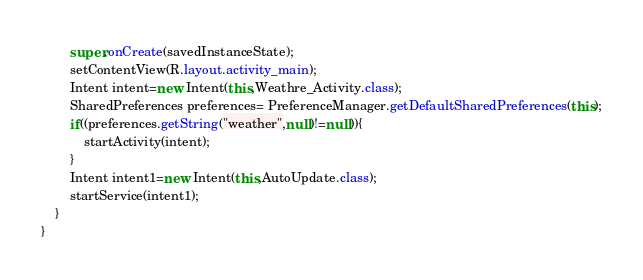Convert code to text. <code><loc_0><loc_0><loc_500><loc_500><_Java_>        super.onCreate(savedInstanceState);
        setContentView(R.layout.activity_main);
        Intent intent=new Intent(this,Weathre_Activity.class);
        SharedPreferences preferences= PreferenceManager.getDefaultSharedPreferences(this);
        if((preferences.getString("weather",null)!=null)){
            startActivity(intent);
        }
        Intent intent1=new Intent(this,AutoUpdate.class);
        startService(intent1);
    }
}
</code> 